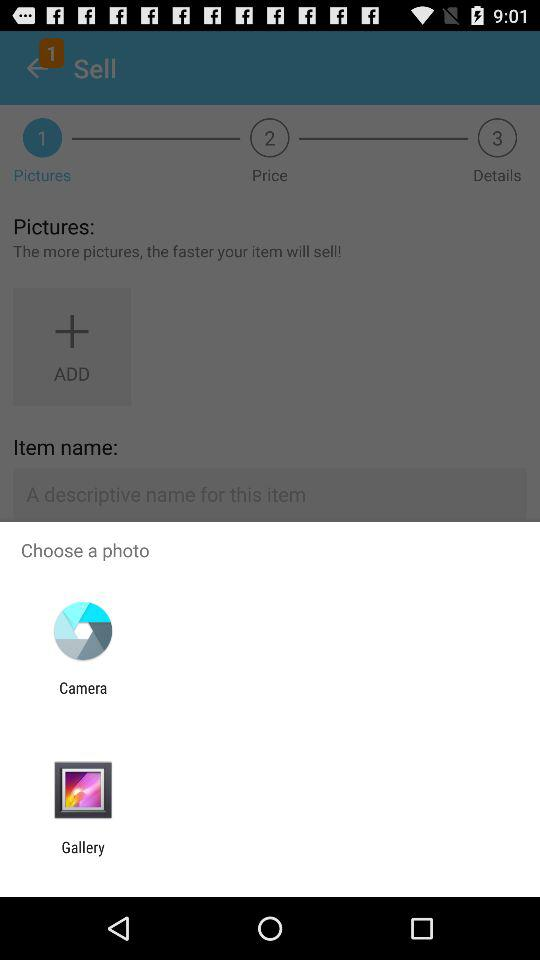What applications can be used to choose a photo? The applications that can be used to choose a photo are "Camera" and "Gallery". 